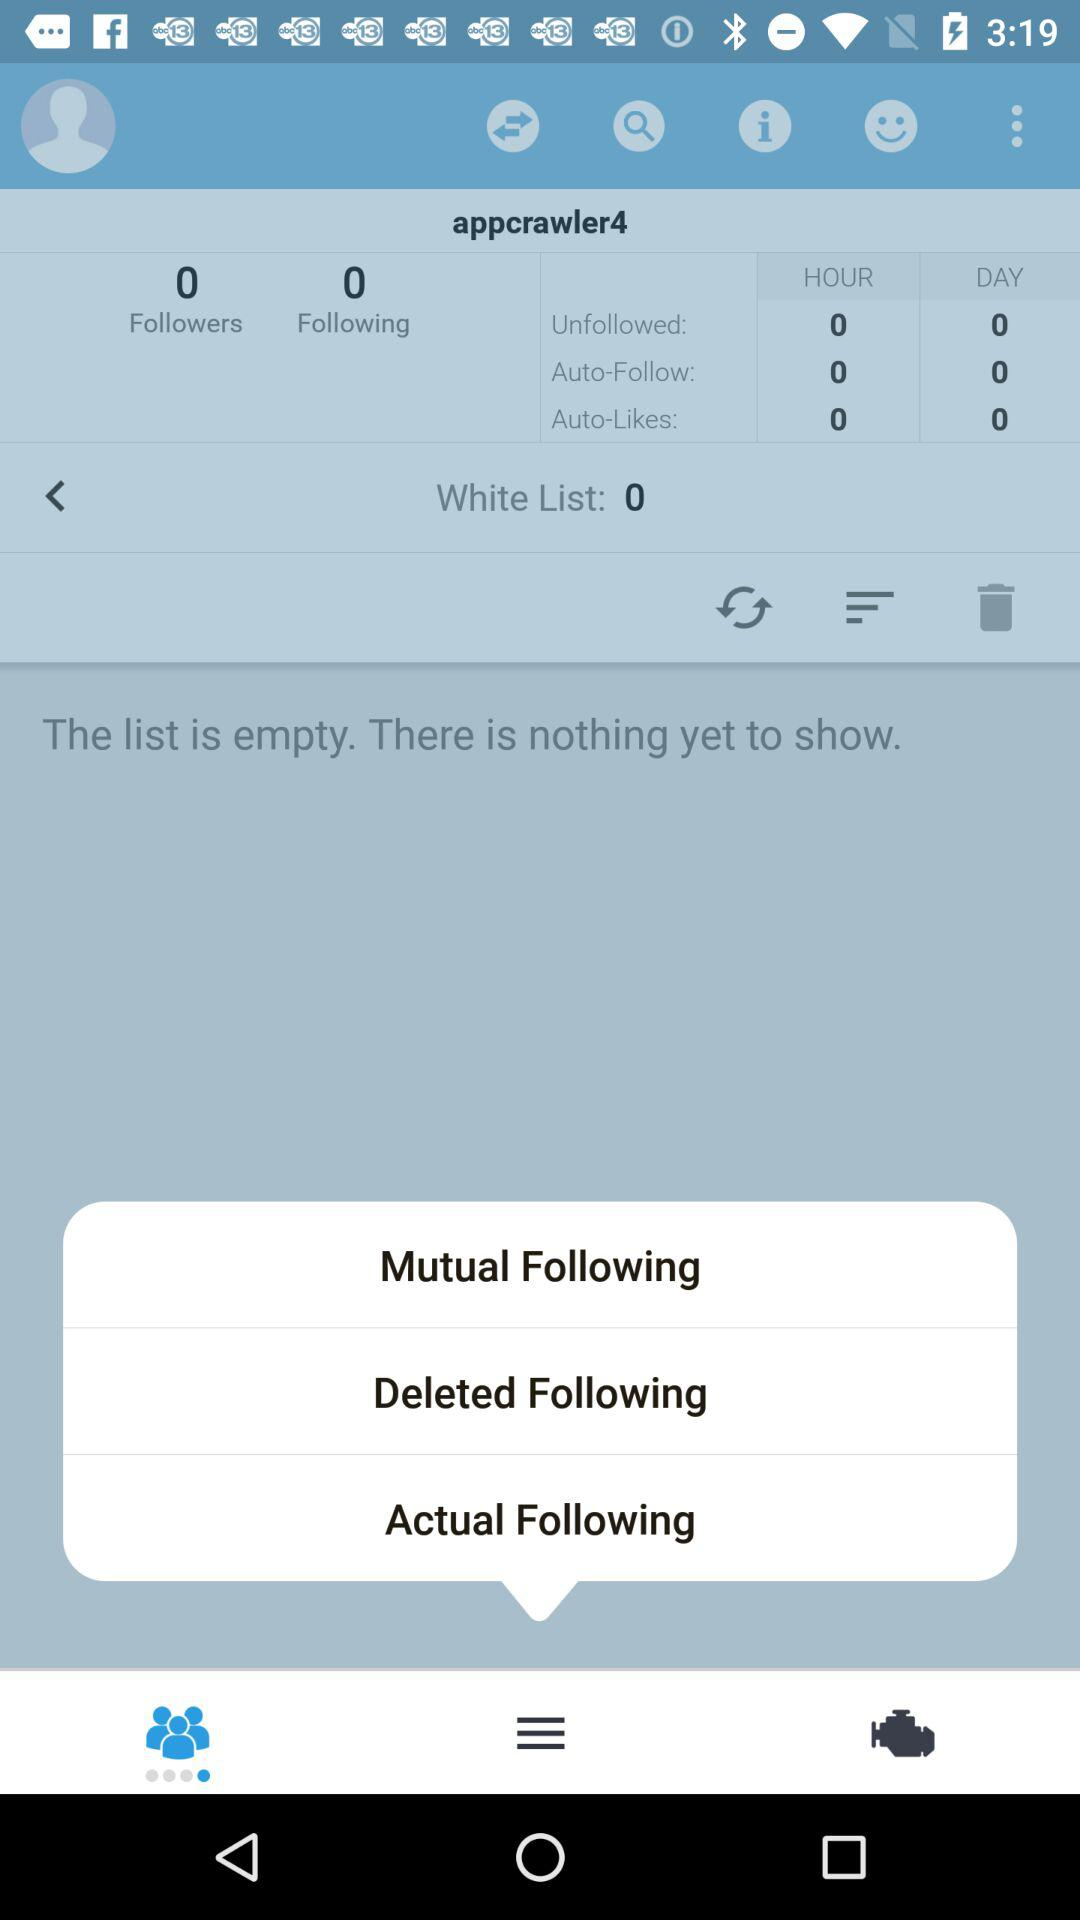How many auto-likes do I have in an hour? You have 0 auto-likes in an hour. 